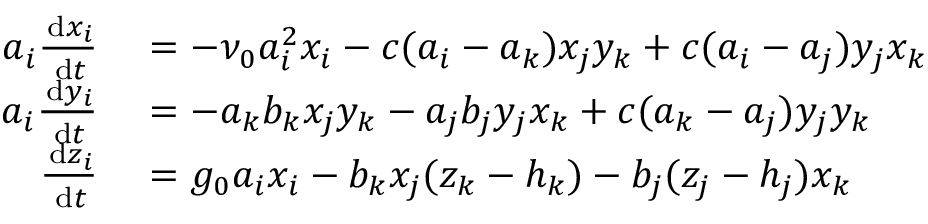<formula> <loc_0><loc_0><loc_500><loc_500>\begin{array} { r l } { \, a _ { i } \frac { \, d x _ { i } } { \, d t } } & = - \nu _ { 0 } a _ { i } ^ { 2 } x _ { i } - c ( a _ { i } - a _ { k } ) x _ { j } y _ { k } + c ( a _ { i } - a _ { j } ) y _ { j } x _ { k } } \\ { \, a _ { i } \frac { \, d y _ { i } } { \, d t } } & = - a _ { k } b _ { k } x _ { j } y _ { k } - a _ { j } b _ { j } y _ { j } x _ { k } + c ( a _ { k } - a _ { j } ) y _ { j } y _ { k } } \\ { \, \frac { \, d z _ { i } } { \, d t } } & = g _ { 0 } a _ { i } x _ { i } - b _ { k } x _ { j } ( z _ { k } - h _ { k } ) - b _ { j } ( z _ { j } - h _ { j } ) x _ { k } } \end{array}</formula> 